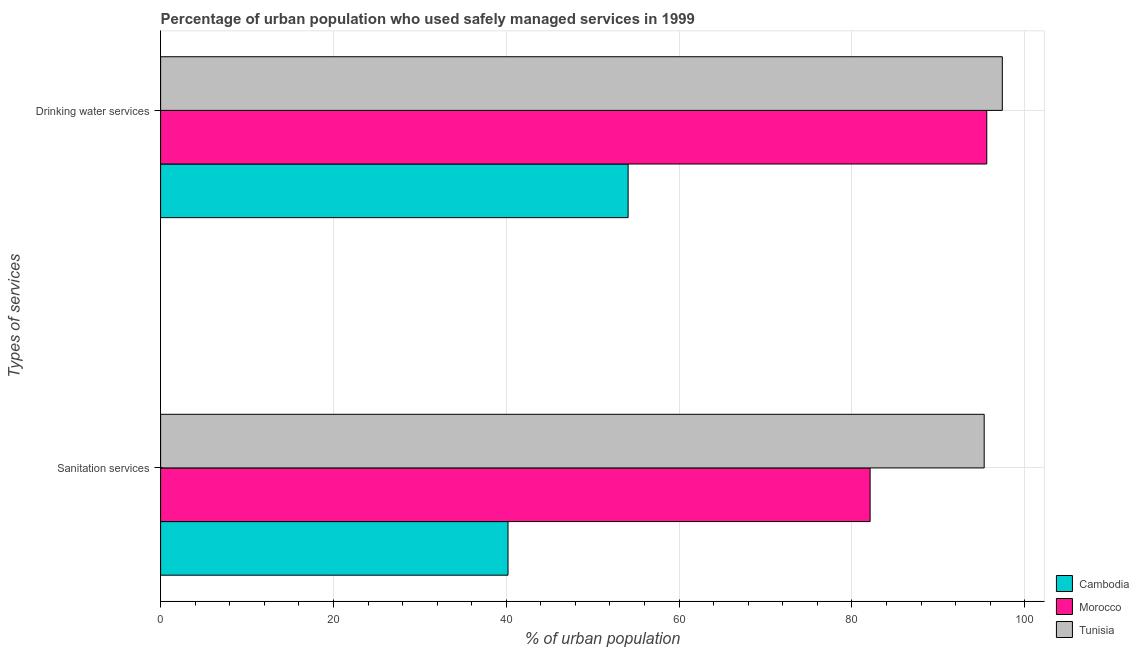Are the number of bars per tick equal to the number of legend labels?
Give a very brief answer. Yes. How many bars are there on the 2nd tick from the top?
Provide a short and direct response. 3. How many bars are there on the 2nd tick from the bottom?
Ensure brevity in your answer.  3. What is the label of the 1st group of bars from the top?
Offer a very short reply. Drinking water services. What is the percentage of urban population who used sanitation services in Morocco?
Offer a terse response. 82.1. Across all countries, what is the maximum percentage of urban population who used drinking water services?
Provide a succinct answer. 97.4. Across all countries, what is the minimum percentage of urban population who used drinking water services?
Provide a succinct answer. 54.1. In which country was the percentage of urban population who used drinking water services maximum?
Offer a very short reply. Tunisia. In which country was the percentage of urban population who used sanitation services minimum?
Your response must be concise. Cambodia. What is the total percentage of urban population who used drinking water services in the graph?
Your answer should be compact. 247.1. What is the difference between the percentage of urban population who used sanitation services in Cambodia and that in Morocco?
Your response must be concise. -41.9. What is the difference between the percentage of urban population who used drinking water services in Cambodia and the percentage of urban population who used sanitation services in Tunisia?
Offer a terse response. -41.2. What is the average percentage of urban population who used drinking water services per country?
Offer a very short reply. 82.37. In how many countries, is the percentage of urban population who used drinking water services greater than 48 %?
Offer a terse response. 3. What is the ratio of the percentage of urban population who used sanitation services in Tunisia to that in Cambodia?
Your answer should be compact. 2.37. Is the percentage of urban population who used drinking water services in Tunisia less than that in Morocco?
Keep it short and to the point. No. What does the 2nd bar from the top in Sanitation services represents?
Give a very brief answer. Morocco. What does the 1st bar from the bottom in Sanitation services represents?
Offer a very short reply. Cambodia. Are all the bars in the graph horizontal?
Your answer should be very brief. Yes. Are the values on the major ticks of X-axis written in scientific E-notation?
Provide a succinct answer. No. Does the graph contain grids?
Make the answer very short. Yes. How many legend labels are there?
Your answer should be compact. 3. What is the title of the graph?
Provide a succinct answer. Percentage of urban population who used safely managed services in 1999. What is the label or title of the X-axis?
Provide a succinct answer. % of urban population. What is the label or title of the Y-axis?
Make the answer very short. Types of services. What is the % of urban population of Cambodia in Sanitation services?
Keep it short and to the point. 40.2. What is the % of urban population of Morocco in Sanitation services?
Your response must be concise. 82.1. What is the % of urban population in Tunisia in Sanitation services?
Provide a succinct answer. 95.3. What is the % of urban population in Cambodia in Drinking water services?
Your response must be concise. 54.1. What is the % of urban population of Morocco in Drinking water services?
Your answer should be compact. 95.6. What is the % of urban population of Tunisia in Drinking water services?
Offer a terse response. 97.4. Across all Types of services, what is the maximum % of urban population of Cambodia?
Your response must be concise. 54.1. Across all Types of services, what is the maximum % of urban population in Morocco?
Give a very brief answer. 95.6. Across all Types of services, what is the maximum % of urban population of Tunisia?
Offer a very short reply. 97.4. Across all Types of services, what is the minimum % of urban population of Cambodia?
Your answer should be very brief. 40.2. Across all Types of services, what is the minimum % of urban population of Morocco?
Keep it short and to the point. 82.1. Across all Types of services, what is the minimum % of urban population in Tunisia?
Make the answer very short. 95.3. What is the total % of urban population of Cambodia in the graph?
Give a very brief answer. 94.3. What is the total % of urban population of Morocco in the graph?
Offer a terse response. 177.7. What is the total % of urban population of Tunisia in the graph?
Your answer should be very brief. 192.7. What is the difference between the % of urban population in Cambodia in Sanitation services and that in Drinking water services?
Your answer should be very brief. -13.9. What is the difference between the % of urban population of Morocco in Sanitation services and that in Drinking water services?
Ensure brevity in your answer.  -13.5. What is the difference between the % of urban population in Cambodia in Sanitation services and the % of urban population in Morocco in Drinking water services?
Ensure brevity in your answer.  -55.4. What is the difference between the % of urban population in Cambodia in Sanitation services and the % of urban population in Tunisia in Drinking water services?
Your answer should be very brief. -57.2. What is the difference between the % of urban population of Morocco in Sanitation services and the % of urban population of Tunisia in Drinking water services?
Provide a succinct answer. -15.3. What is the average % of urban population of Cambodia per Types of services?
Ensure brevity in your answer.  47.15. What is the average % of urban population in Morocco per Types of services?
Your answer should be very brief. 88.85. What is the average % of urban population of Tunisia per Types of services?
Make the answer very short. 96.35. What is the difference between the % of urban population in Cambodia and % of urban population in Morocco in Sanitation services?
Make the answer very short. -41.9. What is the difference between the % of urban population in Cambodia and % of urban population in Tunisia in Sanitation services?
Provide a short and direct response. -55.1. What is the difference between the % of urban population of Cambodia and % of urban population of Morocco in Drinking water services?
Offer a terse response. -41.5. What is the difference between the % of urban population of Cambodia and % of urban population of Tunisia in Drinking water services?
Offer a terse response. -43.3. What is the difference between the % of urban population of Morocco and % of urban population of Tunisia in Drinking water services?
Keep it short and to the point. -1.8. What is the ratio of the % of urban population in Cambodia in Sanitation services to that in Drinking water services?
Give a very brief answer. 0.74. What is the ratio of the % of urban population in Morocco in Sanitation services to that in Drinking water services?
Provide a succinct answer. 0.86. What is the ratio of the % of urban population in Tunisia in Sanitation services to that in Drinking water services?
Your response must be concise. 0.98. What is the difference between the highest and the second highest % of urban population in Cambodia?
Offer a terse response. 13.9. What is the difference between the highest and the second highest % of urban population in Morocco?
Your answer should be very brief. 13.5. What is the difference between the highest and the lowest % of urban population of Cambodia?
Your answer should be very brief. 13.9. What is the difference between the highest and the lowest % of urban population in Morocco?
Ensure brevity in your answer.  13.5. 